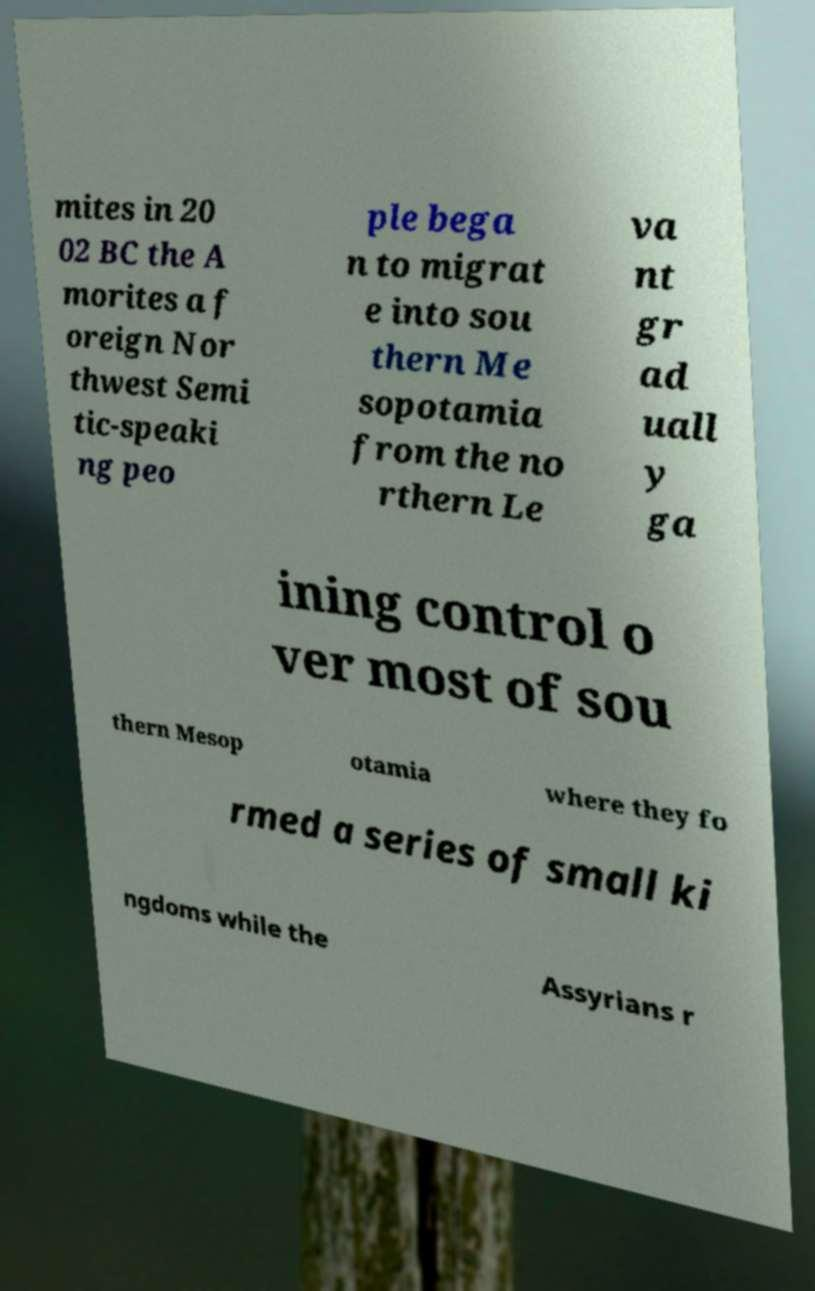There's text embedded in this image that I need extracted. Can you transcribe it verbatim? mites in 20 02 BC the A morites a f oreign Nor thwest Semi tic-speaki ng peo ple bega n to migrat e into sou thern Me sopotamia from the no rthern Le va nt gr ad uall y ga ining control o ver most of sou thern Mesop otamia where they fo rmed a series of small ki ngdoms while the Assyrians r 